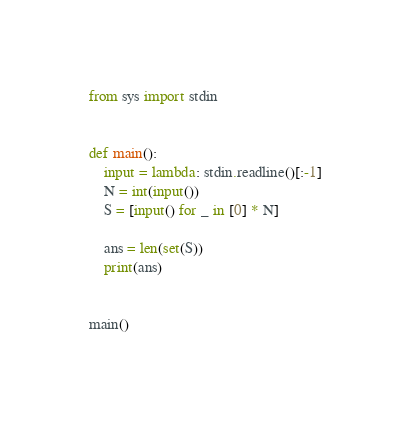<code> <loc_0><loc_0><loc_500><loc_500><_Python_>from sys import stdin


def main():
    input = lambda: stdin.readline()[:-1]
    N = int(input())
    S = [input() for _ in [0] * N]

    ans = len(set(S))
    print(ans)


main()
</code> 